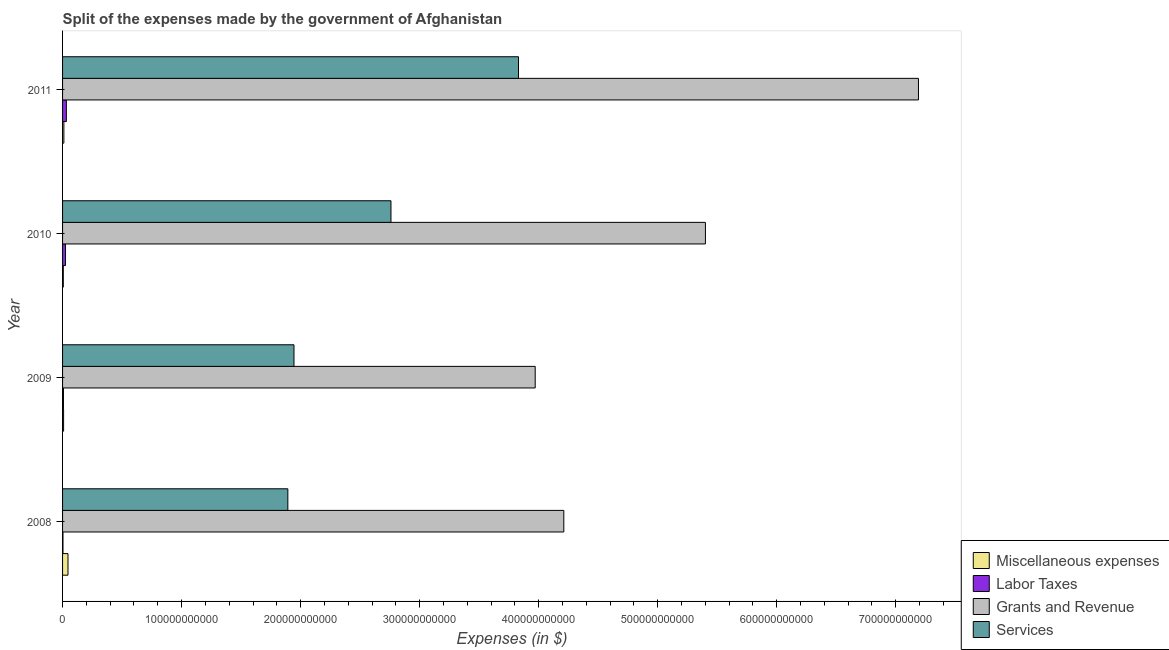How many different coloured bars are there?
Provide a short and direct response. 4. How many groups of bars are there?
Your answer should be very brief. 4. Are the number of bars per tick equal to the number of legend labels?
Your answer should be compact. Yes. How many bars are there on the 2nd tick from the top?
Your answer should be compact. 4. In how many cases, is the number of bars for a given year not equal to the number of legend labels?
Offer a terse response. 0. What is the amount spent on services in 2008?
Offer a terse response. 1.89e+11. Across all years, what is the maximum amount spent on labor taxes?
Give a very brief answer. 3.20e+09. Across all years, what is the minimum amount spent on miscellaneous expenses?
Give a very brief answer. 6.33e+08. In which year was the amount spent on grants and revenue maximum?
Make the answer very short. 2011. In which year was the amount spent on grants and revenue minimum?
Offer a very short reply. 2009. What is the total amount spent on miscellaneous expenses in the graph?
Offer a very short reply. 7.15e+09. What is the difference between the amount spent on grants and revenue in 2008 and that in 2010?
Provide a succinct answer. -1.19e+11. What is the difference between the amount spent on miscellaneous expenses in 2010 and the amount spent on labor taxes in 2008?
Your answer should be compact. 2.92e+08. What is the average amount spent on services per year?
Provide a short and direct response. 2.61e+11. In the year 2008, what is the difference between the amount spent on grants and revenue and amount spent on services?
Make the answer very short. 2.32e+11. In how many years, is the amount spent on miscellaneous expenses greater than 120000000000 $?
Your response must be concise. 0. What is the ratio of the amount spent on grants and revenue in 2008 to that in 2011?
Offer a very short reply. 0.59. Is the amount spent on miscellaneous expenses in 2010 less than that in 2011?
Offer a terse response. Yes. Is the difference between the amount spent on labor taxes in 2008 and 2009 greater than the difference between the amount spent on grants and revenue in 2008 and 2009?
Ensure brevity in your answer.  No. What is the difference between the highest and the second highest amount spent on services?
Provide a succinct answer. 1.07e+11. What is the difference between the highest and the lowest amount spent on grants and revenue?
Offer a very short reply. 3.22e+11. In how many years, is the amount spent on grants and revenue greater than the average amount spent on grants and revenue taken over all years?
Keep it short and to the point. 2. Is the sum of the amount spent on labor taxes in 2009 and 2010 greater than the maximum amount spent on grants and revenue across all years?
Provide a succinct answer. No. Is it the case that in every year, the sum of the amount spent on grants and revenue and amount spent on labor taxes is greater than the sum of amount spent on services and amount spent on miscellaneous expenses?
Give a very brief answer. No. What does the 4th bar from the top in 2009 represents?
Provide a succinct answer. Miscellaneous expenses. What does the 3rd bar from the bottom in 2008 represents?
Keep it short and to the point. Grants and Revenue. How many years are there in the graph?
Keep it short and to the point. 4. What is the difference between two consecutive major ticks on the X-axis?
Keep it short and to the point. 1.00e+11. Are the values on the major ticks of X-axis written in scientific E-notation?
Provide a succinct answer. No. How many legend labels are there?
Your answer should be very brief. 4. How are the legend labels stacked?
Give a very brief answer. Vertical. What is the title of the graph?
Keep it short and to the point. Split of the expenses made by the government of Afghanistan. What is the label or title of the X-axis?
Keep it short and to the point. Expenses (in $). What is the label or title of the Y-axis?
Your answer should be compact. Year. What is the Expenses (in $) in Miscellaneous expenses in 2008?
Make the answer very short. 4.55e+09. What is the Expenses (in $) of Labor Taxes in 2008?
Your answer should be very brief. 3.40e+08. What is the Expenses (in $) in Grants and Revenue in 2008?
Ensure brevity in your answer.  4.21e+11. What is the Expenses (in $) in Services in 2008?
Your answer should be very brief. 1.89e+11. What is the Expenses (in $) in Miscellaneous expenses in 2009?
Your response must be concise. 8.57e+08. What is the Expenses (in $) in Labor Taxes in 2009?
Keep it short and to the point. 7.48e+08. What is the Expenses (in $) in Grants and Revenue in 2009?
Give a very brief answer. 3.97e+11. What is the Expenses (in $) in Services in 2009?
Your answer should be compact. 1.94e+11. What is the Expenses (in $) in Miscellaneous expenses in 2010?
Give a very brief answer. 6.33e+08. What is the Expenses (in $) in Labor Taxes in 2010?
Offer a very short reply. 2.44e+09. What is the Expenses (in $) in Grants and Revenue in 2010?
Keep it short and to the point. 5.40e+11. What is the Expenses (in $) of Services in 2010?
Provide a succinct answer. 2.76e+11. What is the Expenses (in $) in Miscellaneous expenses in 2011?
Your answer should be compact. 1.10e+09. What is the Expenses (in $) in Labor Taxes in 2011?
Offer a terse response. 3.20e+09. What is the Expenses (in $) in Grants and Revenue in 2011?
Make the answer very short. 7.19e+11. What is the Expenses (in $) in Services in 2011?
Give a very brief answer. 3.83e+11. Across all years, what is the maximum Expenses (in $) in Miscellaneous expenses?
Offer a very short reply. 4.55e+09. Across all years, what is the maximum Expenses (in $) of Labor Taxes?
Ensure brevity in your answer.  3.20e+09. Across all years, what is the maximum Expenses (in $) in Grants and Revenue?
Provide a short and direct response. 7.19e+11. Across all years, what is the maximum Expenses (in $) of Services?
Offer a very short reply. 3.83e+11. Across all years, what is the minimum Expenses (in $) of Miscellaneous expenses?
Your answer should be compact. 6.33e+08. Across all years, what is the minimum Expenses (in $) of Labor Taxes?
Give a very brief answer. 3.40e+08. Across all years, what is the minimum Expenses (in $) of Grants and Revenue?
Provide a short and direct response. 3.97e+11. Across all years, what is the minimum Expenses (in $) in Services?
Give a very brief answer. 1.89e+11. What is the total Expenses (in $) in Miscellaneous expenses in the graph?
Offer a very short reply. 7.15e+09. What is the total Expenses (in $) of Labor Taxes in the graph?
Provide a short and direct response. 6.72e+09. What is the total Expenses (in $) of Grants and Revenue in the graph?
Make the answer very short. 2.08e+12. What is the total Expenses (in $) of Services in the graph?
Make the answer very short. 1.04e+12. What is the difference between the Expenses (in $) of Miscellaneous expenses in 2008 and that in 2009?
Your response must be concise. 3.70e+09. What is the difference between the Expenses (in $) of Labor Taxes in 2008 and that in 2009?
Your answer should be very brief. -4.08e+08. What is the difference between the Expenses (in $) in Grants and Revenue in 2008 and that in 2009?
Your answer should be very brief. 2.40e+1. What is the difference between the Expenses (in $) in Services in 2008 and that in 2009?
Keep it short and to the point. -5.15e+09. What is the difference between the Expenses (in $) in Miscellaneous expenses in 2008 and that in 2010?
Provide a succinct answer. 3.92e+09. What is the difference between the Expenses (in $) of Labor Taxes in 2008 and that in 2010?
Offer a very short reply. -2.10e+09. What is the difference between the Expenses (in $) of Grants and Revenue in 2008 and that in 2010?
Your response must be concise. -1.19e+11. What is the difference between the Expenses (in $) in Services in 2008 and that in 2010?
Keep it short and to the point. -8.66e+1. What is the difference between the Expenses (in $) of Miscellaneous expenses in 2008 and that in 2011?
Offer a terse response. 3.45e+09. What is the difference between the Expenses (in $) of Labor Taxes in 2008 and that in 2011?
Provide a succinct answer. -2.86e+09. What is the difference between the Expenses (in $) of Grants and Revenue in 2008 and that in 2011?
Your response must be concise. -2.98e+11. What is the difference between the Expenses (in $) in Services in 2008 and that in 2011?
Make the answer very short. -1.94e+11. What is the difference between the Expenses (in $) in Miscellaneous expenses in 2009 and that in 2010?
Make the answer very short. 2.24e+08. What is the difference between the Expenses (in $) in Labor Taxes in 2009 and that in 2010?
Make the answer very short. -1.69e+09. What is the difference between the Expenses (in $) in Grants and Revenue in 2009 and that in 2010?
Keep it short and to the point. -1.43e+11. What is the difference between the Expenses (in $) in Services in 2009 and that in 2010?
Provide a short and direct response. -8.15e+1. What is the difference between the Expenses (in $) in Miscellaneous expenses in 2009 and that in 2011?
Provide a succinct answer. -2.47e+08. What is the difference between the Expenses (in $) of Labor Taxes in 2009 and that in 2011?
Provide a succinct answer. -2.45e+09. What is the difference between the Expenses (in $) in Grants and Revenue in 2009 and that in 2011?
Offer a very short reply. -3.22e+11. What is the difference between the Expenses (in $) in Services in 2009 and that in 2011?
Offer a very short reply. -1.89e+11. What is the difference between the Expenses (in $) of Miscellaneous expenses in 2010 and that in 2011?
Your answer should be very brief. -4.72e+08. What is the difference between the Expenses (in $) in Labor Taxes in 2010 and that in 2011?
Make the answer very short. -7.64e+08. What is the difference between the Expenses (in $) of Grants and Revenue in 2010 and that in 2011?
Give a very brief answer. -1.79e+11. What is the difference between the Expenses (in $) of Services in 2010 and that in 2011?
Give a very brief answer. -1.07e+11. What is the difference between the Expenses (in $) of Miscellaneous expenses in 2008 and the Expenses (in $) of Labor Taxes in 2009?
Your answer should be very brief. 3.81e+09. What is the difference between the Expenses (in $) in Miscellaneous expenses in 2008 and the Expenses (in $) in Grants and Revenue in 2009?
Your answer should be compact. -3.93e+11. What is the difference between the Expenses (in $) in Miscellaneous expenses in 2008 and the Expenses (in $) in Services in 2009?
Your response must be concise. -1.90e+11. What is the difference between the Expenses (in $) of Labor Taxes in 2008 and the Expenses (in $) of Grants and Revenue in 2009?
Offer a very short reply. -3.97e+11. What is the difference between the Expenses (in $) of Labor Taxes in 2008 and the Expenses (in $) of Services in 2009?
Provide a succinct answer. -1.94e+11. What is the difference between the Expenses (in $) of Grants and Revenue in 2008 and the Expenses (in $) of Services in 2009?
Provide a short and direct response. 2.27e+11. What is the difference between the Expenses (in $) of Miscellaneous expenses in 2008 and the Expenses (in $) of Labor Taxes in 2010?
Ensure brevity in your answer.  2.12e+09. What is the difference between the Expenses (in $) of Miscellaneous expenses in 2008 and the Expenses (in $) of Grants and Revenue in 2010?
Your answer should be compact. -5.36e+11. What is the difference between the Expenses (in $) of Miscellaneous expenses in 2008 and the Expenses (in $) of Services in 2010?
Offer a terse response. -2.71e+11. What is the difference between the Expenses (in $) of Labor Taxes in 2008 and the Expenses (in $) of Grants and Revenue in 2010?
Keep it short and to the point. -5.40e+11. What is the difference between the Expenses (in $) in Labor Taxes in 2008 and the Expenses (in $) in Services in 2010?
Make the answer very short. -2.76e+11. What is the difference between the Expenses (in $) in Grants and Revenue in 2008 and the Expenses (in $) in Services in 2010?
Provide a short and direct response. 1.45e+11. What is the difference between the Expenses (in $) of Miscellaneous expenses in 2008 and the Expenses (in $) of Labor Taxes in 2011?
Provide a succinct answer. 1.36e+09. What is the difference between the Expenses (in $) of Miscellaneous expenses in 2008 and the Expenses (in $) of Grants and Revenue in 2011?
Make the answer very short. -7.15e+11. What is the difference between the Expenses (in $) of Miscellaneous expenses in 2008 and the Expenses (in $) of Services in 2011?
Provide a succinct answer. -3.79e+11. What is the difference between the Expenses (in $) in Labor Taxes in 2008 and the Expenses (in $) in Grants and Revenue in 2011?
Offer a very short reply. -7.19e+11. What is the difference between the Expenses (in $) of Labor Taxes in 2008 and the Expenses (in $) of Services in 2011?
Give a very brief answer. -3.83e+11. What is the difference between the Expenses (in $) in Grants and Revenue in 2008 and the Expenses (in $) in Services in 2011?
Your answer should be very brief. 3.81e+1. What is the difference between the Expenses (in $) of Miscellaneous expenses in 2009 and the Expenses (in $) of Labor Taxes in 2010?
Offer a very short reply. -1.58e+09. What is the difference between the Expenses (in $) of Miscellaneous expenses in 2009 and the Expenses (in $) of Grants and Revenue in 2010?
Your response must be concise. -5.39e+11. What is the difference between the Expenses (in $) of Miscellaneous expenses in 2009 and the Expenses (in $) of Services in 2010?
Provide a succinct answer. -2.75e+11. What is the difference between the Expenses (in $) in Labor Taxes in 2009 and the Expenses (in $) in Grants and Revenue in 2010?
Keep it short and to the point. -5.39e+11. What is the difference between the Expenses (in $) in Labor Taxes in 2009 and the Expenses (in $) in Services in 2010?
Offer a very short reply. -2.75e+11. What is the difference between the Expenses (in $) of Grants and Revenue in 2009 and the Expenses (in $) of Services in 2010?
Give a very brief answer. 1.21e+11. What is the difference between the Expenses (in $) of Miscellaneous expenses in 2009 and the Expenses (in $) of Labor Taxes in 2011?
Your answer should be compact. -2.34e+09. What is the difference between the Expenses (in $) of Miscellaneous expenses in 2009 and the Expenses (in $) of Grants and Revenue in 2011?
Your answer should be very brief. -7.18e+11. What is the difference between the Expenses (in $) of Miscellaneous expenses in 2009 and the Expenses (in $) of Services in 2011?
Keep it short and to the point. -3.82e+11. What is the difference between the Expenses (in $) in Labor Taxes in 2009 and the Expenses (in $) in Grants and Revenue in 2011?
Ensure brevity in your answer.  -7.18e+11. What is the difference between the Expenses (in $) of Labor Taxes in 2009 and the Expenses (in $) of Services in 2011?
Give a very brief answer. -3.82e+11. What is the difference between the Expenses (in $) of Grants and Revenue in 2009 and the Expenses (in $) of Services in 2011?
Make the answer very short. 1.40e+1. What is the difference between the Expenses (in $) of Miscellaneous expenses in 2010 and the Expenses (in $) of Labor Taxes in 2011?
Provide a short and direct response. -2.57e+09. What is the difference between the Expenses (in $) in Miscellaneous expenses in 2010 and the Expenses (in $) in Grants and Revenue in 2011?
Make the answer very short. -7.19e+11. What is the difference between the Expenses (in $) in Miscellaneous expenses in 2010 and the Expenses (in $) in Services in 2011?
Provide a succinct answer. -3.82e+11. What is the difference between the Expenses (in $) of Labor Taxes in 2010 and the Expenses (in $) of Grants and Revenue in 2011?
Your answer should be very brief. -7.17e+11. What is the difference between the Expenses (in $) of Labor Taxes in 2010 and the Expenses (in $) of Services in 2011?
Give a very brief answer. -3.81e+11. What is the difference between the Expenses (in $) of Grants and Revenue in 2010 and the Expenses (in $) of Services in 2011?
Provide a succinct answer. 1.57e+11. What is the average Expenses (in $) of Miscellaneous expenses per year?
Your answer should be very brief. 1.79e+09. What is the average Expenses (in $) in Labor Taxes per year?
Offer a very short reply. 1.68e+09. What is the average Expenses (in $) in Grants and Revenue per year?
Your answer should be compact. 5.19e+11. What is the average Expenses (in $) of Services per year?
Your answer should be very brief. 2.61e+11. In the year 2008, what is the difference between the Expenses (in $) in Miscellaneous expenses and Expenses (in $) in Labor Taxes?
Offer a very short reply. 4.21e+09. In the year 2008, what is the difference between the Expenses (in $) of Miscellaneous expenses and Expenses (in $) of Grants and Revenue?
Give a very brief answer. -4.17e+11. In the year 2008, what is the difference between the Expenses (in $) of Miscellaneous expenses and Expenses (in $) of Services?
Make the answer very short. -1.85e+11. In the year 2008, what is the difference between the Expenses (in $) in Labor Taxes and Expenses (in $) in Grants and Revenue?
Your answer should be compact. -4.21e+11. In the year 2008, what is the difference between the Expenses (in $) of Labor Taxes and Expenses (in $) of Services?
Your response must be concise. -1.89e+11. In the year 2008, what is the difference between the Expenses (in $) in Grants and Revenue and Expenses (in $) in Services?
Your response must be concise. 2.32e+11. In the year 2009, what is the difference between the Expenses (in $) of Miscellaneous expenses and Expenses (in $) of Labor Taxes?
Ensure brevity in your answer.  1.09e+08. In the year 2009, what is the difference between the Expenses (in $) in Miscellaneous expenses and Expenses (in $) in Grants and Revenue?
Give a very brief answer. -3.96e+11. In the year 2009, what is the difference between the Expenses (in $) of Miscellaneous expenses and Expenses (in $) of Services?
Your answer should be very brief. -1.94e+11. In the year 2009, what is the difference between the Expenses (in $) in Labor Taxes and Expenses (in $) in Grants and Revenue?
Keep it short and to the point. -3.96e+11. In the year 2009, what is the difference between the Expenses (in $) in Labor Taxes and Expenses (in $) in Services?
Your response must be concise. -1.94e+11. In the year 2009, what is the difference between the Expenses (in $) of Grants and Revenue and Expenses (in $) of Services?
Keep it short and to the point. 2.03e+11. In the year 2010, what is the difference between the Expenses (in $) of Miscellaneous expenses and Expenses (in $) of Labor Taxes?
Provide a short and direct response. -1.80e+09. In the year 2010, what is the difference between the Expenses (in $) in Miscellaneous expenses and Expenses (in $) in Grants and Revenue?
Provide a succinct answer. -5.40e+11. In the year 2010, what is the difference between the Expenses (in $) in Miscellaneous expenses and Expenses (in $) in Services?
Provide a short and direct response. -2.75e+11. In the year 2010, what is the difference between the Expenses (in $) in Labor Taxes and Expenses (in $) in Grants and Revenue?
Keep it short and to the point. -5.38e+11. In the year 2010, what is the difference between the Expenses (in $) in Labor Taxes and Expenses (in $) in Services?
Offer a terse response. -2.73e+11. In the year 2010, what is the difference between the Expenses (in $) in Grants and Revenue and Expenses (in $) in Services?
Provide a succinct answer. 2.64e+11. In the year 2011, what is the difference between the Expenses (in $) of Miscellaneous expenses and Expenses (in $) of Labor Taxes?
Offer a terse response. -2.09e+09. In the year 2011, what is the difference between the Expenses (in $) of Miscellaneous expenses and Expenses (in $) of Grants and Revenue?
Provide a short and direct response. -7.18e+11. In the year 2011, what is the difference between the Expenses (in $) of Miscellaneous expenses and Expenses (in $) of Services?
Ensure brevity in your answer.  -3.82e+11. In the year 2011, what is the difference between the Expenses (in $) of Labor Taxes and Expenses (in $) of Grants and Revenue?
Give a very brief answer. -7.16e+11. In the year 2011, what is the difference between the Expenses (in $) in Labor Taxes and Expenses (in $) in Services?
Offer a terse response. -3.80e+11. In the year 2011, what is the difference between the Expenses (in $) of Grants and Revenue and Expenses (in $) of Services?
Your response must be concise. 3.36e+11. What is the ratio of the Expenses (in $) of Miscellaneous expenses in 2008 to that in 2009?
Ensure brevity in your answer.  5.31. What is the ratio of the Expenses (in $) of Labor Taxes in 2008 to that in 2009?
Provide a short and direct response. 0.46. What is the ratio of the Expenses (in $) of Grants and Revenue in 2008 to that in 2009?
Ensure brevity in your answer.  1.06. What is the ratio of the Expenses (in $) in Services in 2008 to that in 2009?
Provide a short and direct response. 0.97. What is the ratio of the Expenses (in $) in Miscellaneous expenses in 2008 to that in 2010?
Your answer should be compact. 7.2. What is the ratio of the Expenses (in $) of Labor Taxes in 2008 to that in 2010?
Keep it short and to the point. 0.14. What is the ratio of the Expenses (in $) of Grants and Revenue in 2008 to that in 2010?
Your response must be concise. 0.78. What is the ratio of the Expenses (in $) in Services in 2008 to that in 2010?
Make the answer very short. 0.69. What is the ratio of the Expenses (in $) in Miscellaneous expenses in 2008 to that in 2011?
Your answer should be compact. 4.12. What is the ratio of the Expenses (in $) of Labor Taxes in 2008 to that in 2011?
Your answer should be compact. 0.11. What is the ratio of the Expenses (in $) of Grants and Revenue in 2008 to that in 2011?
Offer a very short reply. 0.59. What is the ratio of the Expenses (in $) of Services in 2008 to that in 2011?
Offer a terse response. 0.49. What is the ratio of the Expenses (in $) in Miscellaneous expenses in 2009 to that in 2010?
Provide a succinct answer. 1.35. What is the ratio of the Expenses (in $) of Labor Taxes in 2009 to that in 2010?
Your answer should be very brief. 0.31. What is the ratio of the Expenses (in $) of Grants and Revenue in 2009 to that in 2010?
Offer a terse response. 0.74. What is the ratio of the Expenses (in $) in Services in 2009 to that in 2010?
Give a very brief answer. 0.7. What is the ratio of the Expenses (in $) of Miscellaneous expenses in 2009 to that in 2011?
Ensure brevity in your answer.  0.78. What is the ratio of the Expenses (in $) of Labor Taxes in 2009 to that in 2011?
Keep it short and to the point. 0.23. What is the ratio of the Expenses (in $) of Grants and Revenue in 2009 to that in 2011?
Keep it short and to the point. 0.55. What is the ratio of the Expenses (in $) in Services in 2009 to that in 2011?
Give a very brief answer. 0.51. What is the ratio of the Expenses (in $) of Miscellaneous expenses in 2010 to that in 2011?
Provide a short and direct response. 0.57. What is the ratio of the Expenses (in $) in Labor Taxes in 2010 to that in 2011?
Keep it short and to the point. 0.76. What is the ratio of the Expenses (in $) of Grants and Revenue in 2010 to that in 2011?
Your response must be concise. 0.75. What is the ratio of the Expenses (in $) of Services in 2010 to that in 2011?
Provide a succinct answer. 0.72. What is the difference between the highest and the second highest Expenses (in $) in Miscellaneous expenses?
Provide a short and direct response. 3.45e+09. What is the difference between the highest and the second highest Expenses (in $) in Labor Taxes?
Give a very brief answer. 7.64e+08. What is the difference between the highest and the second highest Expenses (in $) of Grants and Revenue?
Provide a short and direct response. 1.79e+11. What is the difference between the highest and the second highest Expenses (in $) of Services?
Provide a succinct answer. 1.07e+11. What is the difference between the highest and the lowest Expenses (in $) in Miscellaneous expenses?
Offer a terse response. 3.92e+09. What is the difference between the highest and the lowest Expenses (in $) in Labor Taxes?
Offer a terse response. 2.86e+09. What is the difference between the highest and the lowest Expenses (in $) of Grants and Revenue?
Your answer should be compact. 3.22e+11. What is the difference between the highest and the lowest Expenses (in $) of Services?
Provide a short and direct response. 1.94e+11. 